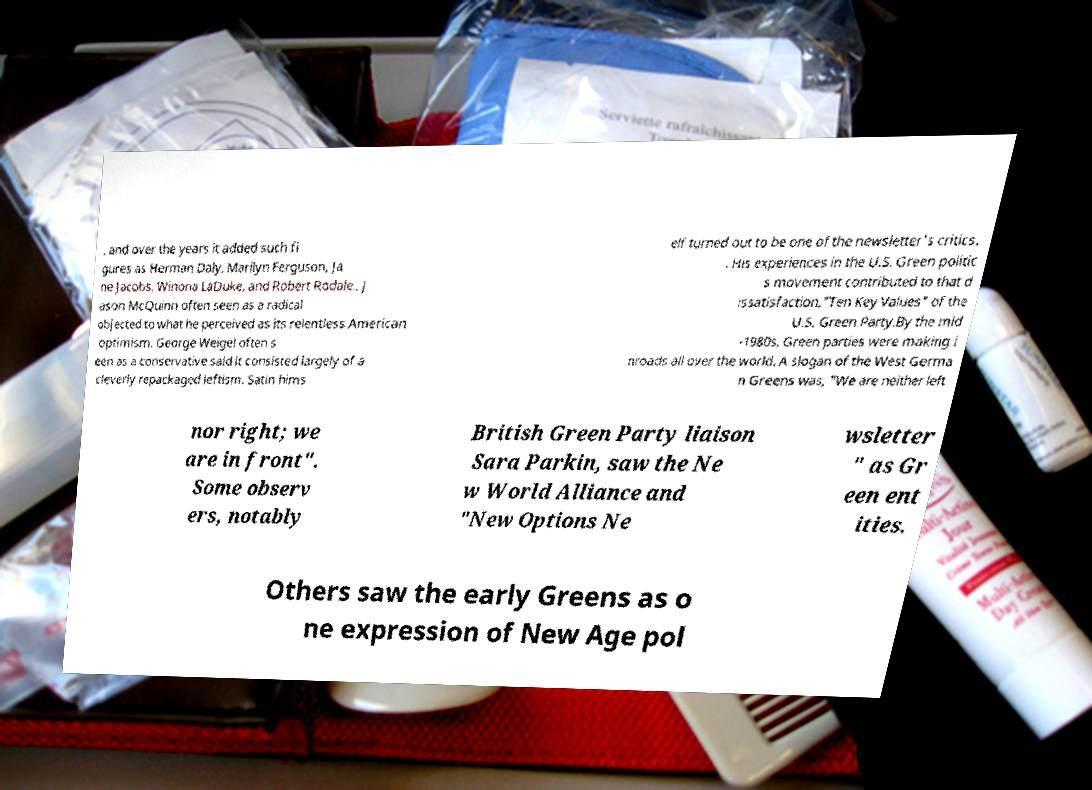Can you read and provide the text displayed in the image?This photo seems to have some interesting text. Can you extract and type it out for me? , and over the years it added such fi gures as Herman Daly, Marilyn Ferguson, Ja ne Jacobs, Winona LaDuke, and Robert Rodale.. J ason McQuinn often seen as a radical objected to what he perceived as its relentless American optimism. George Weigel often s een as a conservative said it consisted largely of a cleverly repackaged leftism. Satin hims elf turned out to be one of the newsletter's critics. . His experiences in the U.S. Green politic s movement contributed to that d issatisfaction."Ten Key Values" of the U.S. Green Party.By the mid -1980s, Green parties were making i nroads all over the world. A slogan of the West Germa n Greens was, "We are neither left nor right; we are in front". Some observ ers, notably British Green Party liaison Sara Parkin, saw the Ne w World Alliance and "New Options Ne wsletter " as Gr een ent ities. Others saw the early Greens as o ne expression of New Age pol 